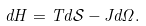<formula> <loc_0><loc_0><loc_500><loc_500>d H = T d \mathcal { S } - J d \Omega .</formula> 